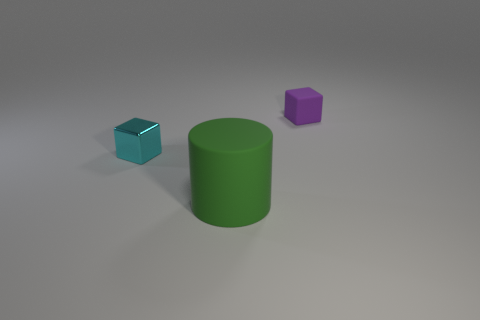Add 2 brown metallic cylinders. How many objects exist? 5 Subtract all cyan cubes. How many cubes are left? 1 Subtract 0 yellow cubes. How many objects are left? 3 Subtract all cylinders. How many objects are left? 2 Subtract 1 cylinders. How many cylinders are left? 0 Subtract all brown cubes. Subtract all gray spheres. How many cubes are left? 2 Subtract all green cubes. How many red cylinders are left? 0 Subtract all large red matte cubes. Subtract all rubber objects. How many objects are left? 1 Add 3 green things. How many green things are left? 4 Add 3 small gray matte objects. How many small gray matte objects exist? 3 